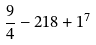Convert formula to latex. <formula><loc_0><loc_0><loc_500><loc_500>\frac { 9 } { 4 } - 2 1 8 + 1 ^ { 7 }</formula> 